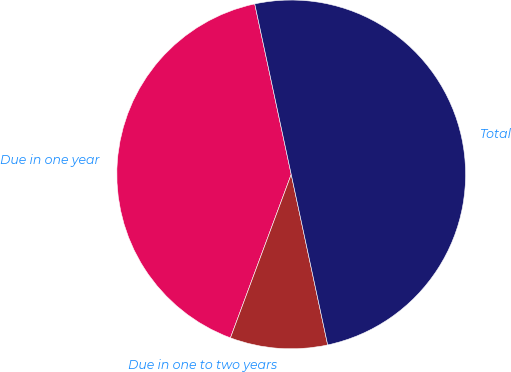Convert chart. <chart><loc_0><loc_0><loc_500><loc_500><pie_chart><fcel>Due in one year<fcel>Due in one to two years<fcel>Total<nl><fcel>40.98%<fcel>9.02%<fcel>50.0%<nl></chart> 